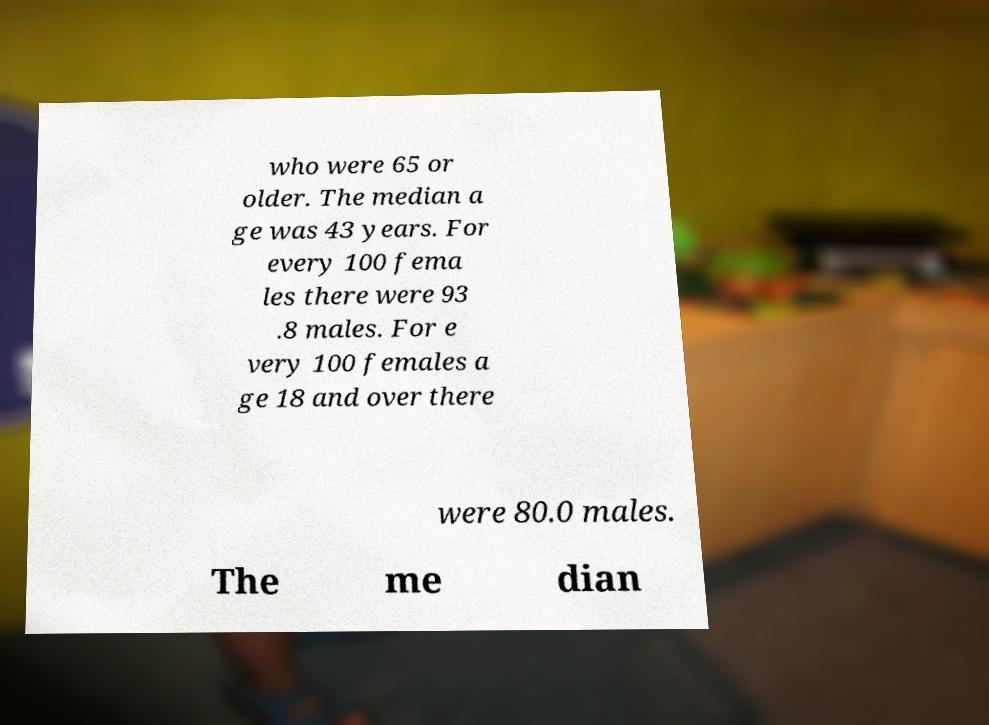Can you accurately transcribe the text from the provided image for me? who were 65 or older. The median a ge was 43 years. For every 100 fema les there were 93 .8 males. For e very 100 females a ge 18 and over there were 80.0 males. The me dian 